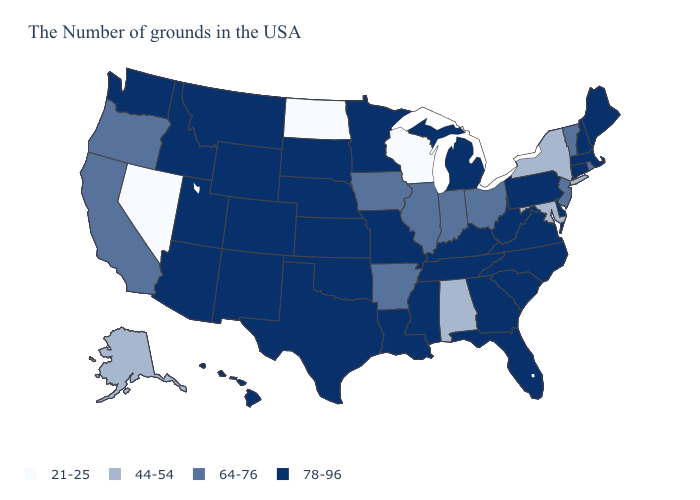Which states hav the highest value in the Northeast?
Keep it brief. Maine, Massachusetts, New Hampshire, Connecticut, Pennsylvania. Which states have the highest value in the USA?
Short answer required. Maine, Massachusetts, New Hampshire, Connecticut, Delaware, Pennsylvania, Virginia, North Carolina, South Carolina, West Virginia, Florida, Georgia, Michigan, Kentucky, Tennessee, Mississippi, Louisiana, Missouri, Minnesota, Kansas, Nebraska, Oklahoma, Texas, South Dakota, Wyoming, Colorado, New Mexico, Utah, Montana, Arizona, Idaho, Washington, Hawaii. Which states hav the highest value in the South?
Short answer required. Delaware, Virginia, North Carolina, South Carolina, West Virginia, Florida, Georgia, Kentucky, Tennessee, Mississippi, Louisiana, Oklahoma, Texas. What is the lowest value in the USA?
Quick response, please. 21-25. What is the value of Tennessee?
Quick response, please. 78-96. Name the states that have a value in the range 21-25?
Concise answer only. Wisconsin, North Dakota, Nevada. Name the states that have a value in the range 44-54?
Write a very short answer. New York, Maryland, Alabama, Alaska. What is the value of Tennessee?
Be succinct. 78-96. Does the first symbol in the legend represent the smallest category?
Short answer required. Yes. Does Pennsylvania have the same value as Alaska?
Be succinct. No. Name the states that have a value in the range 44-54?
Write a very short answer. New York, Maryland, Alabama, Alaska. How many symbols are there in the legend?
Answer briefly. 4. Does Kansas have a higher value than Oklahoma?
Be succinct. No. What is the value of New Jersey?
Give a very brief answer. 64-76. Among the states that border Oregon , does Idaho have the lowest value?
Answer briefly. No. 